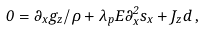Convert formula to latex. <formula><loc_0><loc_0><loc_500><loc_500>0 = \partial _ { x } g _ { z } / \rho + \lambda _ { p } E \partial _ { x } ^ { 2 } s _ { x } + J _ { z } d \, ,</formula> 